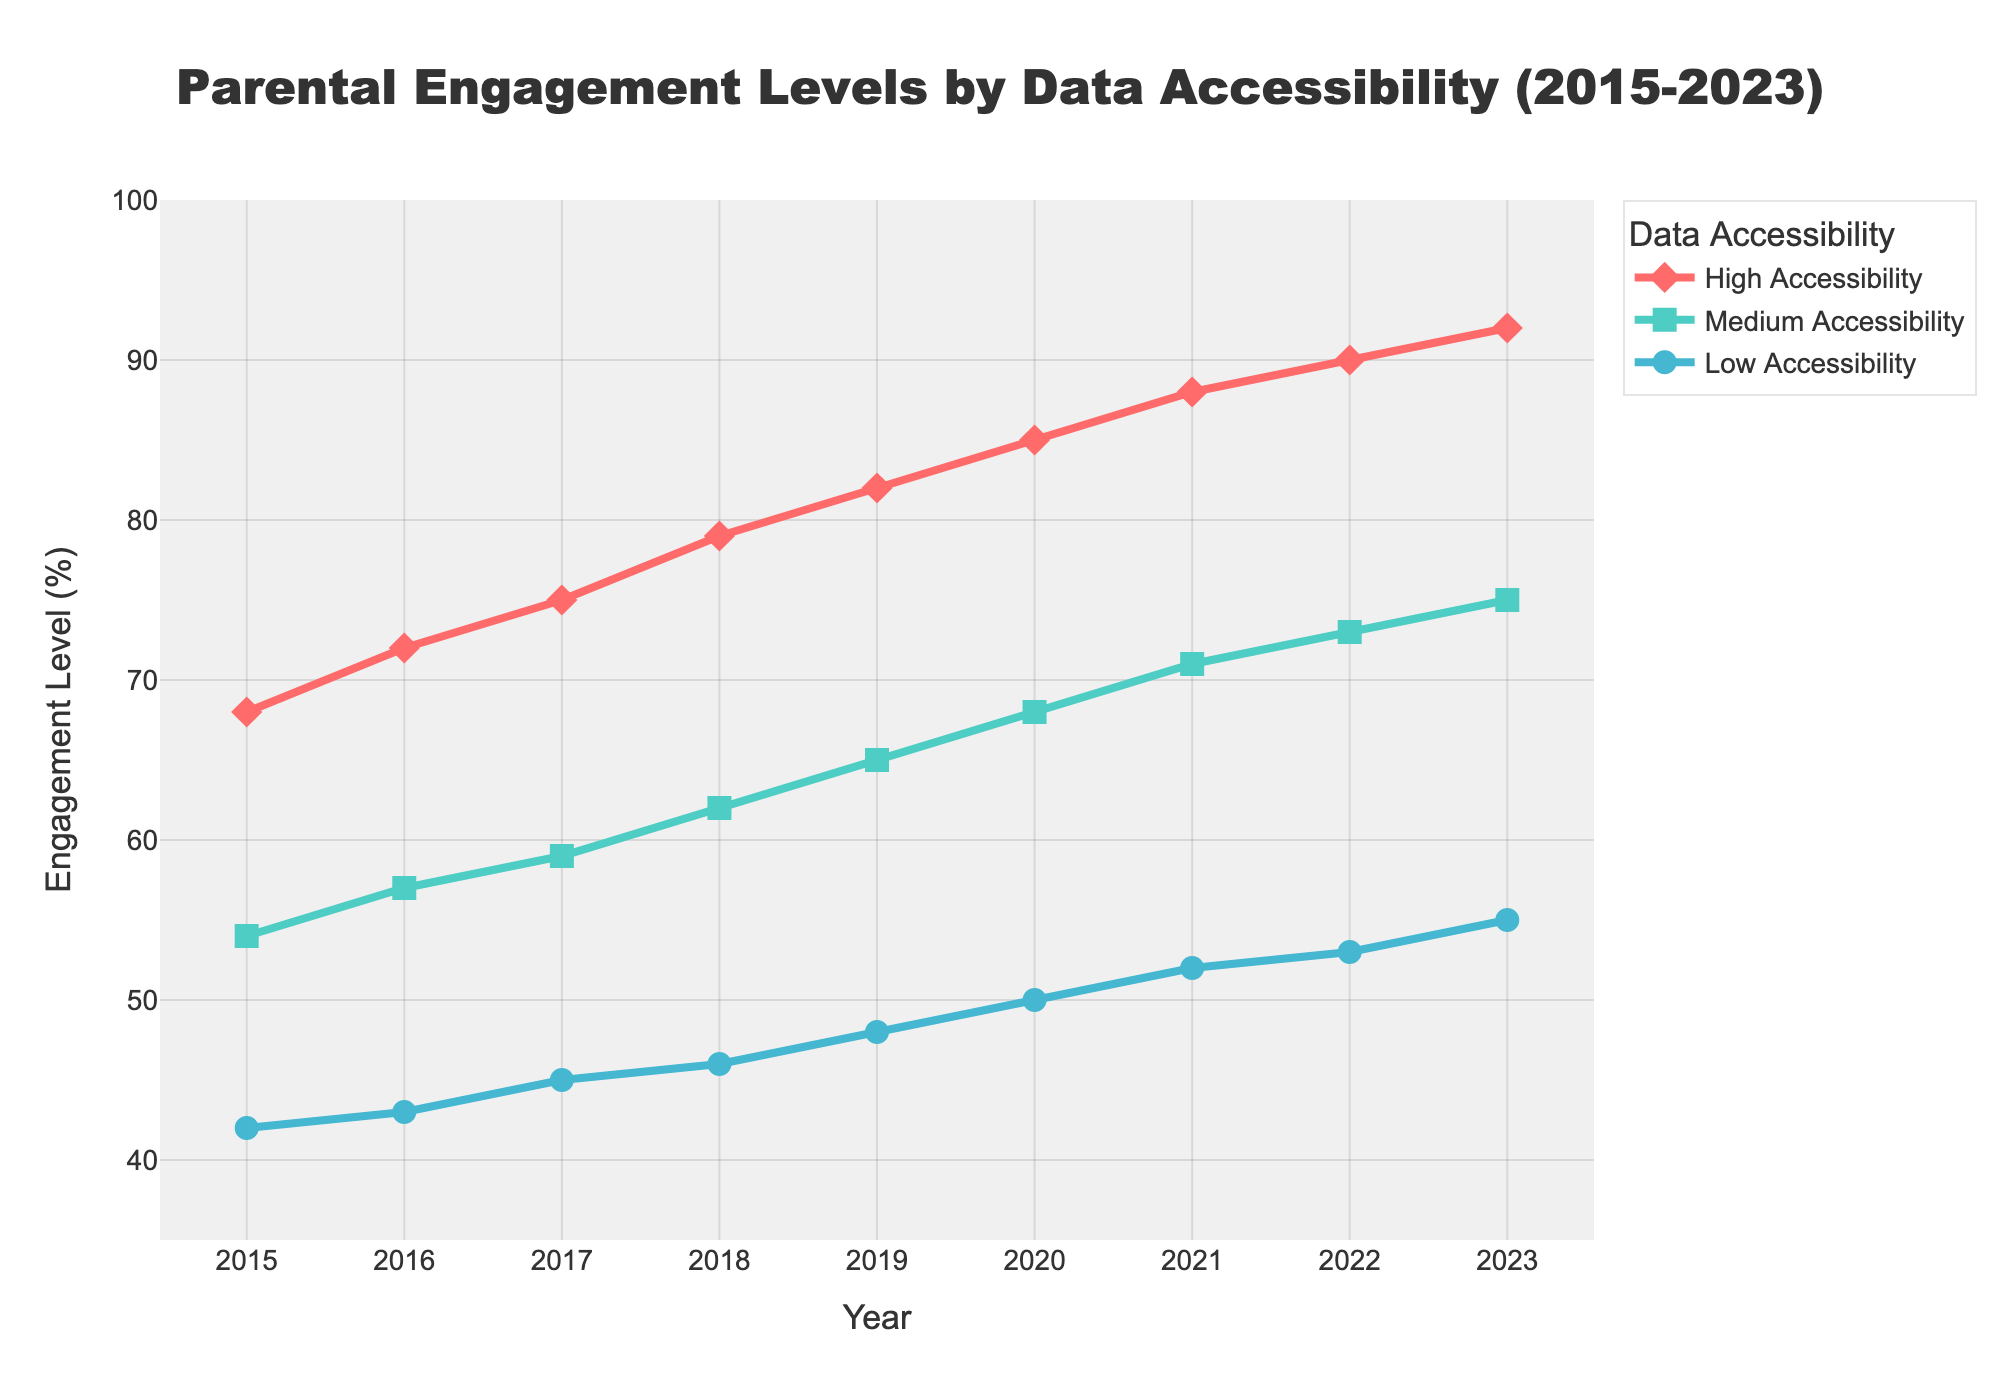what is the difference in parental engagement levels between high and low accessibility in 2023? In 2023, high accessibility has an engagement level of 92%, and low accessibility has an engagement level of 55%. The difference is 92% - 55%.
Answer: 37% How much did the parental engagement level for medium accessibility increase from 2015 to 2023? In 2015, the engagement level for medium accessibility was 54%. In 2023, it is 75%. The increase is 75% - 54%.
Answer: 21% What is the trend of parental engagement levels for all types of data accessibility from 2015 to 2023? The line chart shows that the engagement levels for all types of data accessibility (high, medium, and low) have increased each year from 2015 to 2023.
Answer: Increasing Which accessibility type had the highest parental engagement level in 2019? In 2019, high accessibility had the highest parental engagement level with 82%.
Answer: High Accessibility Compare the parental engagement level of medium accessibility in 2018 to the highest level of low accessibility between 2015 and 2023. Which is higher? The parental engagement level for medium accessibility in 2018 is 62%. The highest level of low accessibility from 2015 to 2023 is 55% in 2023. Therefore, 62% is higher than 55%.
Answer: Medium Accessibility in 2018 Predict the parental engagement level for low accessibility if the trend continues into 2024. From 2015 to 2023, the engagement level for low accessibility increased by an average of (55 - 42) / 8 = 1.625 percentage points per year. Adding this to the 2023 level (55%), the predicted level for 2024 is 55 + 1.625.
Answer: ~57% What is the average parental engagement level for high accessibility from 2015 to 2023? The engagement levels for high accessibility from 2015 to 2023 are [68, 72, 75, 79, 82, 85, 88, 90, 92]. The sum of these values is 731. Dividing by the number of years (9), the average is 731 / 9.
Answer: ~81.22% By what year did all accessibility types reach an engagement level of at least 50%? By the year 2020, all accessibility types (high, medium, and low) had engagement levels of at least 50%.
Answer: 2020 Among the three types of data accessibility, which showed the greatest absolute increase in engagement levels from 2015 to 2023? High accessibility increased from 68% to 92% (24 percentage points).
Medium accessibility increased from 54% to 75% (21 percentage points).
Low accessibility increased from 42% to 55% (13 percentage points).
High accessibility showed the greatest absolute increase.
Answer: High Accessibility 